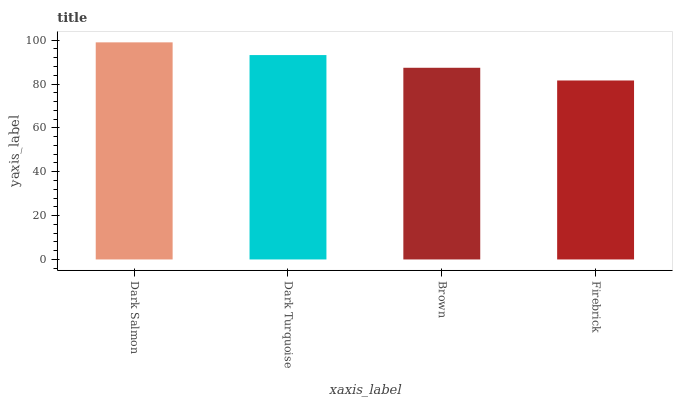Is Firebrick the minimum?
Answer yes or no. Yes. Is Dark Salmon the maximum?
Answer yes or no. Yes. Is Dark Turquoise the minimum?
Answer yes or no. No. Is Dark Turquoise the maximum?
Answer yes or no. No. Is Dark Salmon greater than Dark Turquoise?
Answer yes or no. Yes. Is Dark Turquoise less than Dark Salmon?
Answer yes or no. Yes. Is Dark Turquoise greater than Dark Salmon?
Answer yes or no. No. Is Dark Salmon less than Dark Turquoise?
Answer yes or no. No. Is Dark Turquoise the high median?
Answer yes or no. Yes. Is Brown the low median?
Answer yes or no. Yes. Is Dark Salmon the high median?
Answer yes or no. No. Is Dark Salmon the low median?
Answer yes or no. No. 